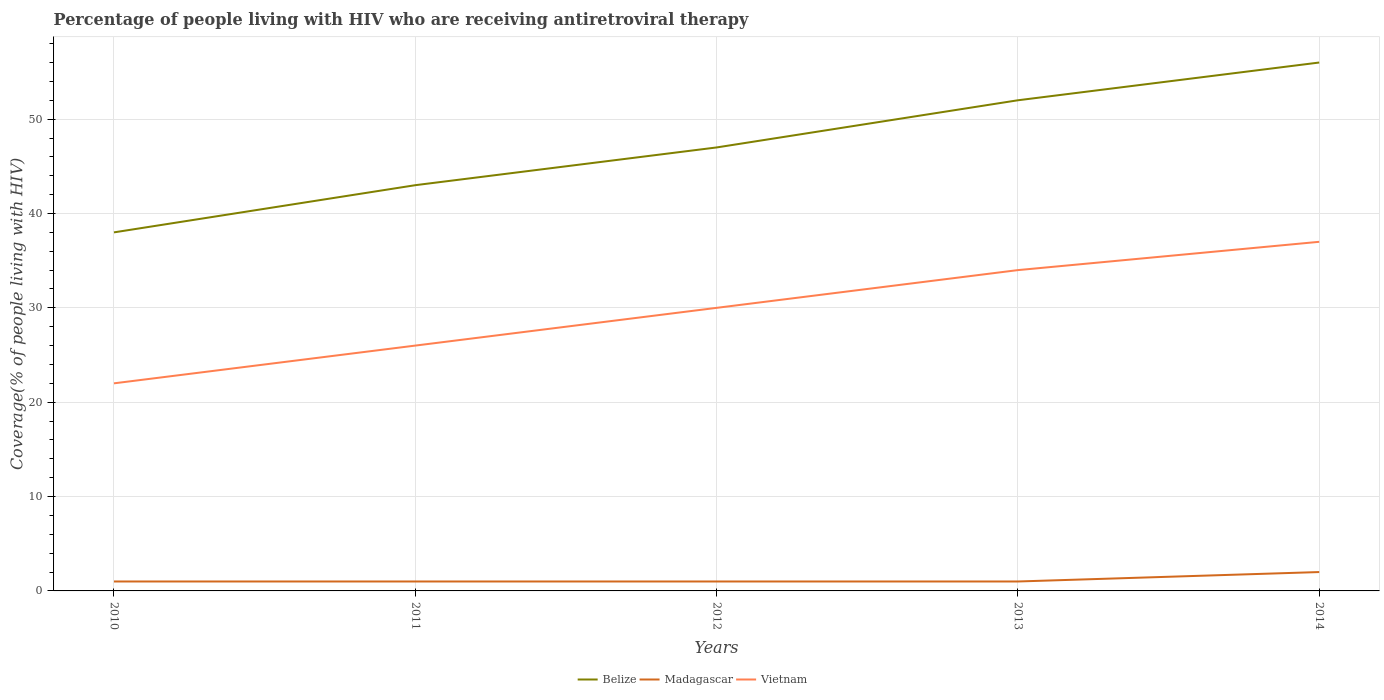Does the line corresponding to Belize intersect with the line corresponding to Vietnam?
Provide a short and direct response. No. Across all years, what is the maximum percentage of the HIV infected people who are receiving antiretroviral therapy in Vietnam?
Offer a very short reply. 22. In which year was the percentage of the HIV infected people who are receiving antiretroviral therapy in Madagascar maximum?
Ensure brevity in your answer.  2010. What is the total percentage of the HIV infected people who are receiving antiretroviral therapy in Belize in the graph?
Provide a short and direct response. -14. What is the difference between the highest and the second highest percentage of the HIV infected people who are receiving antiretroviral therapy in Vietnam?
Your response must be concise. 15. How many lines are there?
Offer a very short reply. 3. Are the values on the major ticks of Y-axis written in scientific E-notation?
Your response must be concise. No. Where does the legend appear in the graph?
Offer a very short reply. Bottom center. How many legend labels are there?
Provide a short and direct response. 3. What is the title of the graph?
Provide a succinct answer. Percentage of people living with HIV who are receiving antiretroviral therapy. Does "Turkmenistan" appear as one of the legend labels in the graph?
Offer a terse response. No. What is the label or title of the X-axis?
Give a very brief answer. Years. What is the label or title of the Y-axis?
Your response must be concise. Coverage(% of people living with HIV). What is the Coverage(% of people living with HIV) of Madagascar in 2010?
Give a very brief answer. 1. What is the Coverage(% of people living with HIV) of Belize in 2011?
Your answer should be compact. 43. What is the Coverage(% of people living with HIV) in Madagascar in 2011?
Offer a terse response. 1. What is the Coverage(% of people living with HIV) of Belize in 2012?
Offer a very short reply. 47. What is the Coverage(% of people living with HIV) of Vietnam in 2013?
Ensure brevity in your answer.  34. What is the Coverage(% of people living with HIV) in Belize in 2014?
Offer a very short reply. 56. What is the Coverage(% of people living with HIV) of Vietnam in 2014?
Ensure brevity in your answer.  37. What is the total Coverage(% of people living with HIV) in Belize in the graph?
Provide a succinct answer. 236. What is the total Coverage(% of people living with HIV) in Madagascar in the graph?
Make the answer very short. 6. What is the total Coverage(% of people living with HIV) in Vietnam in the graph?
Your answer should be very brief. 149. What is the difference between the Coverage(% of people living with HIV) of Belize in 2010 and that in 2011?
Your answer should be very brief. -5. What is the difference between the Coverage(% of people living with HIV) in Madagascar in 2010 and that in 2011?
Your response must be concise. 0. What is the difference between the Coverage(% of people living with HIV) of Madagascar in 2010 and that in 2013?
Keep it short and to the point. 0. What is the difference between the Coverage(% of people living with HIV) in Vietnam in 2010 and that in 2013?
Your answer should be very brief. -12. What is the difference between the Coverage(% of people living with HIV) of Madagascar in 2010 and that in 2014?
Provide a short and direct response. -1. What is the difference between the Coverage(% of people living with HIV) of Vietnam in 2010 and that in 2014?
Your answer should be compact. -15. What is the difference between the Coverage(% of people living with HIV) of Madagascar in 2011 and that in 2013?
Offer a terse response. 0. What is the difference between the Coverage(% of people living with HIV) in Vietnam in 2011 and that in 2013?
Offer a terse response. -8. What is the difference between the Coverage(% of people living with HIV) of Belize in 2011 and that in 2014?
Provide a succinct answer. -13. What is the difference between the Coverage(% of people living with HIV) of Madagascar in 2011 and that in 2014?
Your answer should be compact. -1. What is the difference between the Coverage(% of people living with HIV) in Vietnam in 2011 and that in 2014?
Keep it short and to the point. -11. What is the difference between the Coverage(% of people living with HIV) in Belize in 2012 and that in 2013?
Ensure brevity in your answer.  -5. What is the difference between the Coverage(% of people living with HIV) in Vietnam in 2012 and that in 2013?
Your response must be concise. -4. What is the difference between the Coverage(% of people living with HIV) in Madagascar in 2012 and that in 2014?
Your response must be concise. -1. What is the difference between the Coverage(% of people living with HIV) in Belize in 2013 and that in 2014?
Offer a very short reply. -4. What is the difference between the Coverage(% of people living with HIV) of Belize in 2010 and the Coverage(% of people living with HIV) of Vietnam in 2011?
Your response must be concise. 12. What is the difference between the Coverage(% of people living with HIV) in Belize in 2010 and the Coverage(% of people living with HIV) in Vietnam in 2012?
Keep it short and to the point. 8. What is the difference between the Coverage(% of people living with HIV) in Madagascar in 2010 and the Coverage(% of people living with HIV) in Vietnam in 2012?
Provide a short and direct response. -29. What is the difference between the Coverage(% of people living with HIV) in Belize in 2010 and the Coverage(% of people living with HIV) in Madagascar in 2013?
Your answer should be very brief. 37. What is the difference between the Coverage(% of people living with HIV) in Belize in 2010 and the Coverage(% of people living with HIV) in Vietnam in 2013?
Your answer should be compact. 4. What is the difference between the Coverage(% of people living with HIV) of Madagascar in 2010 and the Coverage(% of people living with HIV) of Vietnam in 2013?
Keep it short and to the point. -33. What is the difference between the Coverage(% of people living with HIV) in Belize in 2010 and the Coverage(% of people living with HIV) in Madagascar in 2014?
Make the answer very short. 36. What is the difference between the Coverage(% of people living with HIV) of Madagascar in 2010 and the Coverage(% of people living with HIV) of Vietnam in 2014?
Offer a terse response. -36. What is the difference between the Coverage(% of people living with HIV) in Belize in 2011 and the Coverage(% of people living with HIV) in Madagascar in 2012?
Provide a succinct answer. 42. What is the difference between the Coverage(% of people living with HIV) in Belize in 2011 and the Coverage(% of people living with HIV) in Vietnam in 2013?
Your answer should be very brief. 9. What is the difference between the Coverage(% of people living with HIV) in Madagascar in 2011 and the Coverage(% of people living with HIV) in Vietnam in 2013?
Offer a very short reply. -33. What is the difference between the Coverage(% of people living with HIV) in Belize in 2011 and the Coverage(% of people living with HIV) in Madagascar in 2014?
Keep it short and to the point. 41. What is the difference between the Coverage(% of people living with HIV) of Belize in 2011 and the Coverage(% of people living with HIV) of Vietnam in 2014?
Provide a short and direct response. 6. What is the difference between the Coverage(% of people living with HIV) in Madagascar in 2011 and the Coverage(% of people living with HIV) in Vietnam in 2014?
Offer a very short reply. -36. What is the difference between the Coverage(% of people living with HIV) of Madagascar in 2012 and the Coverage(% of people living with HIV) of Vietnam in 2013?
Give a very brief answer. -33. What is the difference between the Coverage(% of people living with HIV) of Madagascar in 2012 and the Coverage(% of people living with HIV) of Vietnam in 2014?
Your answer should be compact. -36. What is the difference between the Coverage(% of people living with HIV) in Belize in 2013 and the Coverage(% of people living with HIV) in Madagascar in 2014?
Give a very brief answer. 50. What is the difference between the Coverage(% of people living with HIV) in Madagascar in 2013 and the Coverage(% of people living with HIV) in Vietnam in 2014?
Make the answer very short. -36. What is the average Coverage(% of people living with HIV) in Belize per year?
Your answer should be very brief. 47.2. What is the average Coverage(% of people living with HIV) of Vietnam per year?
Make the answer very short. 29.8. In the year 2010, what is the difference between the Coverage(% of people living with HIV) of Belize and Coverage(% of people living with HIV) of Madagascar?
Ensure brevity in your answer.  37. In the year 2010, what is the difference between the Coverage(% of people living with HIV) of Belize and Coverage(% of people living with HIV) of Vietnam?
Provide a succinct answer. 16. In the year 2011, what is the difference between the Coverage(% of people living with HIV) of Belize and Coverage(% of people living with HIV) of Madagascar?
Offer a very short reply. 42. In the year 2011, what is the difference between the Coverage(% of people living with HIV) in Belize and Coverage(% of people living with HIV) in Vietnam?
Offer a very short reply. 17. In the year 2012, what is the difference between the Coverage(% of people living with HIV) in Belize and Coverage(% of people living with HIV) in Vietnam?
Your response must be concise. 17. In the year 2013, what is the difference between the Coverage(% of people living with HIV) of Belize and Coverage(% of people living with HIV) of Madagascar?
Your answer should be compact. 51. In the year 2013, what is the difference between the Coverage(% of people living with HIV) of Belize and Coverage(% of people living with HIV) of Vietnam?
Provide a short and direct response. 18. In the year 2013, what is the difference between the Coverage(% of people living with HIV) of Madagascar and Coverage(% of people living with HIV) of Vietnam?
Ensure brevity in your answer.  -33. In the year 2014, what is the difference between the Coverage(% of people living with HIV) in Madagascar and Coverage(% of people living with HIV) in Vietnam?
Provide a short and direct response. -35. What is the ratio of the Coverage(% of people living with HIV) in Belize in 2010 to that in 2011?
Your answer should be compact. 0.88. What is the ratio of the Coverage(% of people living with HIV) in Madagascar in 2010 to that in 2011?
Your answer should be very brief. 1. What is the ratio of the Coverage(% of people living with HIV) in Vietnam in 2010 to that in 2011?
Provide a succinct answer. 0.85. What is the ratio of the Coverage(% of people living with HIV) of Belize in 2010 to that in 2012?
Your response must be concise. 0.81. What is the ratio of the Coverage(% of people living with HIV) in Madagascar in 2010 to that in 2012?
Your answer should be very brief. 1. What is the ratio of the Coverage(% of people living with HIV) in Vietnam in 2010 to that in 2012?
Ensure brevity in your answer.  0.73. What is the ratio of the Coverage(% of people living with HIV) in Belize in 2010 to that in 2013?
Offer a very short reply. 0.73. What is the ratio of the Coverage(% of people living with HIV) of Vietnam in 2010 to that in 2013?
Your answer should be very brief. 0.65. What is the ratio of the Coverage(% of people living with HIV) in Belize in 2010 to that in 2014?
Ensure brevity in your answer.  0.68. What is the ratio of the Coverage(% of people living with HIV) of Vietnam in 2010 to that in 2014?
Provide a succinct answer. 0.59. What is the ratio of the Coverage(% of people living with HIV) in Belize in 2011 to that in 2012?
Provide a short and direct response. 0.91. What is the ratio of the Coverage(% of people living with HIV) in Vietnam in 2011 to that in 2012?
Your answer should be compact. 0.87. What is the ratio of the Coverage(% of people living with HIV) of Belize in 2011 to that in 2013?
Offer a terse response. 0.83. What is the ratio of the Coverage(% of people living with HIV) of Vietnam in 2011 to that in 2013?
Offer a very short reply. 0.76. What is the ratio of the Coverage(% of people living with HIV) in Belize in 2011 to that in 2014?
Offer a very short reply. 0.77. What is the ratio of the Coverage(% of people living with HIV) in Madagascar in 2011 to that in 2014?
Make the answer very short. 0.5. What is the ratio of the Coverage(% of people living with HIV) of Vietnam in 2011 to that in 2014?
Make the answer very short. 0.7. What is the ratio of the Coverage(% of people living with HIV) of Belize in 2012 to that in 2013?
Give a very brief answer. 0.9. What is the ratio of the Coverage(% of people living with HIV) in Madagascar in 2012 to that in 2013?
Your response must be concise. 1. What is the ratio of the Coverage(% of people living with HIV) of Vietnam in 2012 to that in 2013?
Offer a very short reply. 0.88. What is the ratio of the Coverage(% of people living with HIV) in Belize in 2012 to that in 2014?
Make the answer very short. 0.84. What is the ratio of the Coverage(% of people living with HIV) of Madagascar in 2012 to that in 2014?
Give a very brief answer. 0.5. What is the ratio of the Coverage(% of people living with HIV) of Vietnam in 2012 to that in 2014?
Your response must be concise. 0.81. What is the ratio of the Coverage(% of people living with HIV) of Belize in 2013 to that in 2014?
Give a very brief answer. 0.93. What is the ratio of the Coverage(% of people living with HIV) of Vietnam in 2013 to that in 2014?
Your response must be concise. 0.92. What is the difference between the highest and the second highest Coverage(% of people living with HIV) in Belize?
Make the answer very short. 4. What is the difference between the highest and the second highest Coverage(% of people living with HIV) of Vietnam?
Make the answer very short. 3. What is the difference between the highest and the lowest Coverage(% of people living with HIV) of Belize?
Your answer should be compact. 18. What is the difference between the highest and the lowest Coverage(% of people living with HIV) of Vietnam?
Your answer should be compact. 15. 